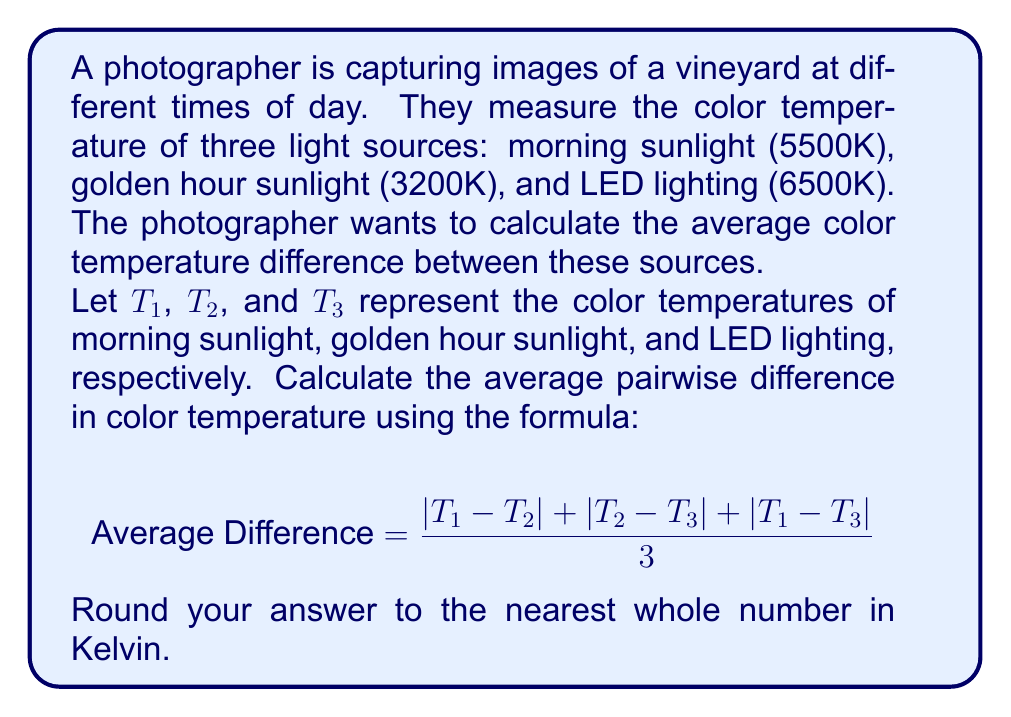Help me with this question. To solve this problem, we'll follow these steps:

1. Identify the given color temperatures:
   $T_1$ (morning sunlight) = 5500K
   $T_2$ (golden hour sunlight) = 3200K
   $T_3$ (LED lighting) = 6500K

2. Calculate the absolute differences between each pair:
   $|T_1 - T_2| = |5500 - 3200| = 2300$
   $|T_2 - T_3| = |3200 - 6500| = 3300$
   $|T_1 - T_3| = |5500 - 6500| = 1000$

3. Sum up the differences:
   $2300 + 3300 + 1000 = 6600$

4. Divide by 3 to get the average:
   $\frac{6600}{3} = 2200$

5. The result is already a whole number, so no rounding is necessary.

Therefore, the average pairwise difference in color temperature is 2200K.
Answer: 2200K 